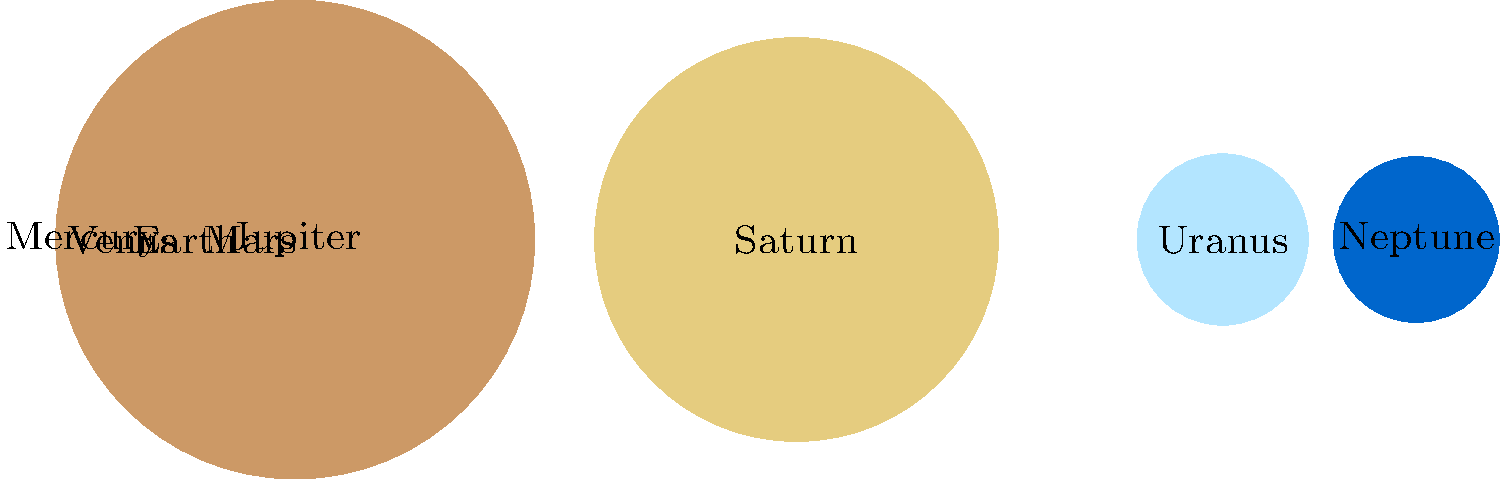As a healthcare professional interested in astronomy, you're studying the relative sizes of planets in our solar system. The image shows scaled representations of the eight planets. Which planet has a diameter approximately 2.5 times larger than Earth's diameter? Let's approach this step-by-step:

1. First, we need to identify Earth in the diagram. Earth is the third planet from the left, colored blue.

2. We need to compare the sizes of the other planets to Earth visually.

3. The planets larger than Earth are Jupiter, Saturn, Uranus, and Neptune (the four rightmost planets).

4. Among these, we're looking for a planet about 2.5 times larger in diameter than Earth.

5. Jupiter and Saturn appear much larger than 2.5 times Earth's size.

6. Uranus and Neptune look closer to the size we're seeking.

7. To determine which is closer to 2.5 times Earth's size, we can use the actual diameters provided in the image creation data:
   - Earth's diameter: 12.8 units
   - Uranus' diameter: 51.1 units
   - Neptune's diameter: 49.5 units

8. Calculate the ratio:
   - Uranus/Earth = 51.1/12.8 ≈ 3.99
   - Neptune/Earth = 49.5/12.8 ≈ 3.87

9. Both are closer to 4 times Earth's diameter than 2.5 times.

10. However, Neptune is slightly closer to 2.5 times (3.87 vs 3.99).

Therefore, Neptune is the closest to being 2.5 times larger than Earth, although it's actually closer to 4 times larger.
Answer: Neptune 